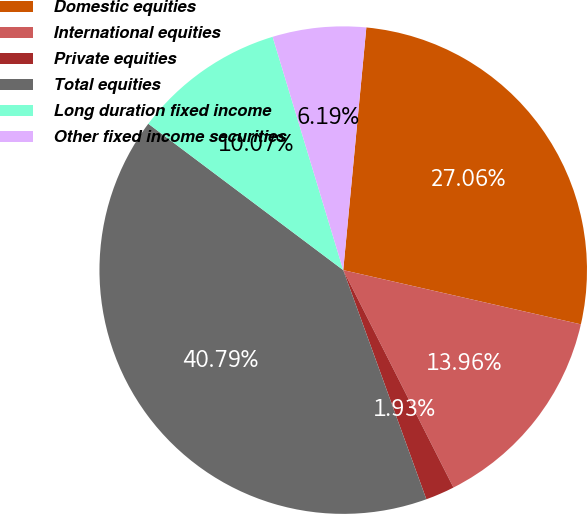<chart> <loc_0><loc_0><loc_500><loc_500><pie_chart><fcel>Domestic equities<fcel>International equities<fcel>Private equities<fcel>Total equities<fcel>Long duration fixed income<fcel>Other fixed income securities<nl><fcel>27.06%<fcel>13.96%<fcel>1.93%<fcel>40.79%<fcel>10.07%<fcel>6.19%<nl></chart> 